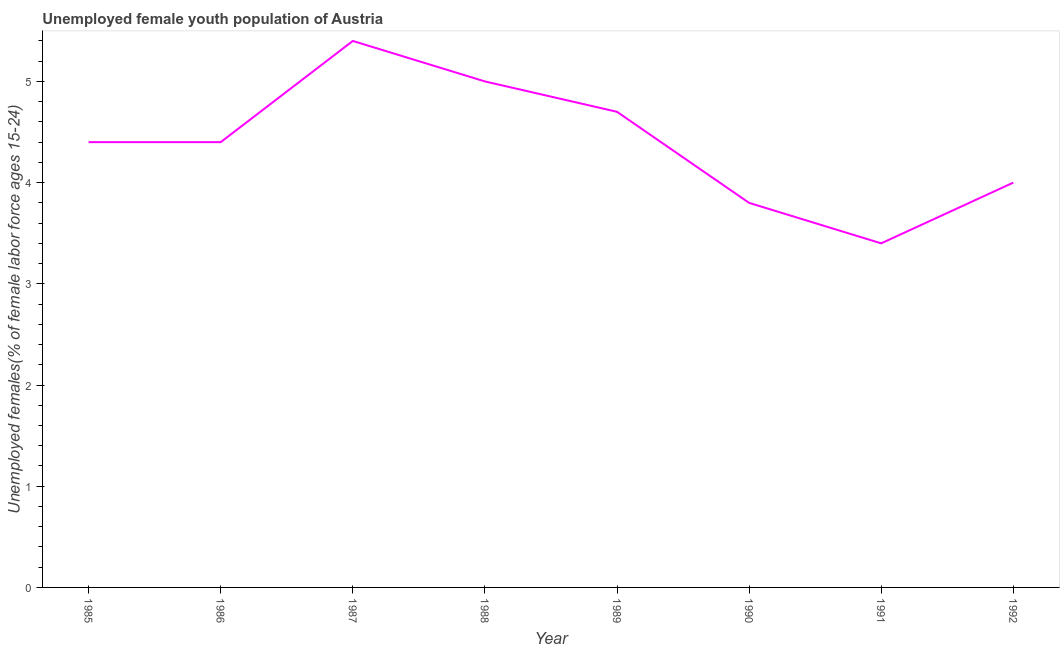What is the unemployed female youth in 1986?
Keep it short and to the point. 4.4. Across all years, what is the maximum unemployed female youth?
Offer a very short reply. 5.4. Across all years, what is the minimum unemployed female youth?
Offer a terse response. 3.4. In which year was the unemployed female youth maximum?
Give a very brief answer. 1987. In which year was the unemployed female youth minimum?
Provide a short and direct response. 1991. What is the sum of the unemployed female youth?
Your answer should be compact. 35.1. What is the difference between the unemployed female youth in 1989 and 1992?
Provide a short and direct response. 0.7. What is the average unemployed female youth per year?
Offer a terse response. 4.39. What is the median unemployed female youth?
Provide a short and direct response. 4.4. In how many years, is the unemployed female youth greater than 4.4 %?
Provide a short and direct response. 5. What is the ratio of the unemployed female youth in 1986 to that in 1990?
Your answer should be compact. 1.16. What is the difference between the highest and the second highest unemployed female youth?
Give a very brief answer. 0.4. What is the difference between the highest and the lowest unemployed female youth?
Keep it short and to the point. 2. In how many years, is the unemployed female youth greater than the average unemployed female youth taken over all years?
Make the answer very short. 5. Does the unemployed female youth monotonically increase over the years?
Keep it short and to the point. No. How many lines are there?
Your answer should be very brief. 1. Are the values on the major ticks of Y-axis written in scientific E-notation?
Provide a short and direct response. No. What is the title of the graph?
Give a very brief answer. Unemployed female youth population of Austria. What is the label or title of the X-axis?
Give a very brief answer. Year. What is the label or title of the Y-axis?
Offer a very short reply. Unemployed females(% of female labor force ages 15-24). What is the Unemployed females(% of female labor force ages 15-24) in 1985?
Offer a very short reply. 4.4. What is the Unemployed females(% of female labor force ages 15-24) in 1986?
Give a very brief answer. 4.4. What is the Unemployed females(% of female labor force ages 15-24) of 1987?
Keep it short and to the point. 5.4. What is the Unemployed females(% of female labor force ages 15-24) in 1988?
Your response must be concise. 5. What is the Unemployed females(% of female labor force ages 15-24) of 1989?
Your answer should be compact. 4.7. What is the Unemployed females(% of female labor force ages 15-24) in 1990?
Offer a very short reply. 3.8. What is the Unemployed females(% of female labor force ages 15-24) in 1991?
Offer a terse response. 3.4. What is the difference between the Unemployed females(% of female labor force ages 15-24) in 1985 and 1986?
Your response must be concise. 0. What is the difference between the Unemployed females(% of female labor force ages 15-24) in 1985 and 1987?
Make the answer very short. -1. What is the difference between the Unemployed females(% of female labor force ages 15-24) in 1985 and 1988?
Make the answer very short. -0.6. What is the difference between the Unemployed females(% of female labor force ages 15-24) in 1985 and 1991?
Your response must be concise. 1. What is the difference between the Unemployed females(% of female labor force ages 15-24) in 1985 and 1992?
Provide a short and direct response. 0.4. What is the difference between the Unemployed females(% of female labor force ages 15-24) in 1986 and 1991?
Offer a very short reply. 1. What is the difference between the Unemployed females(% of female labor force ages 15-24) in 1986 and 1992?
Your answer should be compact. 0.4. What is the difference between the Unemployed females(% of female labor force ages 15-24) in 1987 and 1989?
Give a very brief answer. 0.7. What is the difference between the Unemployed females(% of female labor force ages 15-24) in 1988 and 1990?
Your answer should be very brief. 1.2. What is the difference between the Unemployed females(% of female labor force ages 15-24) in 1988 and 1991?
Provide a short and direct response. 1.6. What is the difference between the Unemployed females(% of female labor force ages 15-24) in 1989 and 1992?
Provide a short and direct response. 0.7. What is the difference between the Unemployed females(% of female labor force ages 15-24) in 1990 and 1992?
Provide a succinct answer. -0.2. What is the difference between the Unemployed females(% of female labor force ages 15-24) in 1991 and 1992?
Your response must be concise. -0.6. What is the ratio of the Unemployed females(% of female labor force ages 15-24) in 1985 to that in 1986?
Make the answer very short. 1. What is the ratio of the Unemployed females(% of female labor force ages 15-24) in 1985 to that in 1987?
Your response must be concise. 0.81. What is the ratio of the Unemployed females(% of female labor force ages 15-24) in 1985 to that in 1988?
Ensure brevity in your answer.  0.88. What is the ratio of the Unemployed females(% of female labor force ages 15-24) in 1985 to that in 1989?
Your response must be concise. 0.94. What is the ratio of the Unemployed females(% of female labor force ages 15-24) in 1985 to that in 1990?
Offer a terse response. 1.16. What is the ratio of the Unemployed females(% of female labor force ages 15-24) in 1985 to that in 1991?
Give a very brief answer. 1.29. What is the ratio of the Unemployed females(% of female labor force ages 15-24) in 1986 to that in 1987?
Your response must be concise. 0.81. What is the ratio of the Unemployed females(% of female labor force ages 15-24) in 1986 to that in 1988?
Give a very brief answer. 0.88. What is the ratio of the Unemployed females(% of female labor force ages 15-24) in 1986 to that in 1989?
Make the answer very short. 0.94. What is the ratio of the Unemployed females(% of female labor force ages 15-24) in 1986 to that in 1990?
Make the answer very short. 1.16. What is the ratio of the Unemployed females(% of female labor force ages 15-24) in 1986 to that in 1991?
Your answer should be very brief. 1.29. What is the ratio of the Unemployed females(% of female labor force ages 15-24) in 1987 to that in 1989?
Offer a very short reply. 1.15. What is the ratio of the Unemployed females(% of female labor force ages 15-24) in 1987 to that in 1990?
Your answer should be very brief. 1.42. What is the ratio of the Unemployed females(% of female labor force ages 15-24) in 1987 to that in 1991?
Give a very brief answer. 1.59. What is the ratio of the Unemployed females(% of female labor force ages 15-24) in 1987 to that in 1992?
Provide a succinct answer. 1.35. What is the ratio of the Unemployed females(% of female labor force ages 15-24) in 1988 to that in 1989?
Give a very brief answer. 1.06. What is the ratio of the Unemployed females(% of female labor force ages 15-24) in 1988 to that in 1990?
Keep it short and to the point. 1.32. What is the ratio of the Unemployed females(% of female labor force ages 15-24) in 1988 to that in 1991?
Offer a very short reply. 1.47. What is the ratio of the Unemployed females(% of female labor force ages 15-24) in 1989 to that in 1990?
Offer a very short reply. 1.24. What is the ratio of the Unemployed females(% of female labor force ages 15-24) in 1989 to that in 1991?
Provide a short and direct response. 1.38. What is the ratio of the Unemployed females(% of female labor force ages 15-24) in 1989 to that in 1992?
Give a very brief answer. 1.18. What is the ratio of the Unemployed females(% of female labor force ages 15-24) in 1990 to that in 1991?
Make the answer very short. 1.12. What is the ratio of the Unemployed females(% of female labor force ages 15-24) in 1991 to that in 1992?
Make the answer very short. 0.85. 